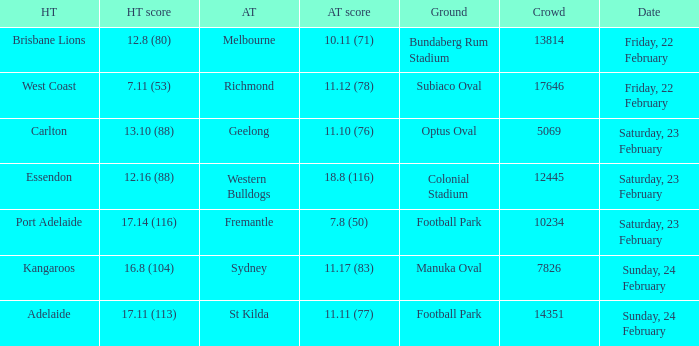On what date did the away team Fremantle play? Saturday, 23 February. 